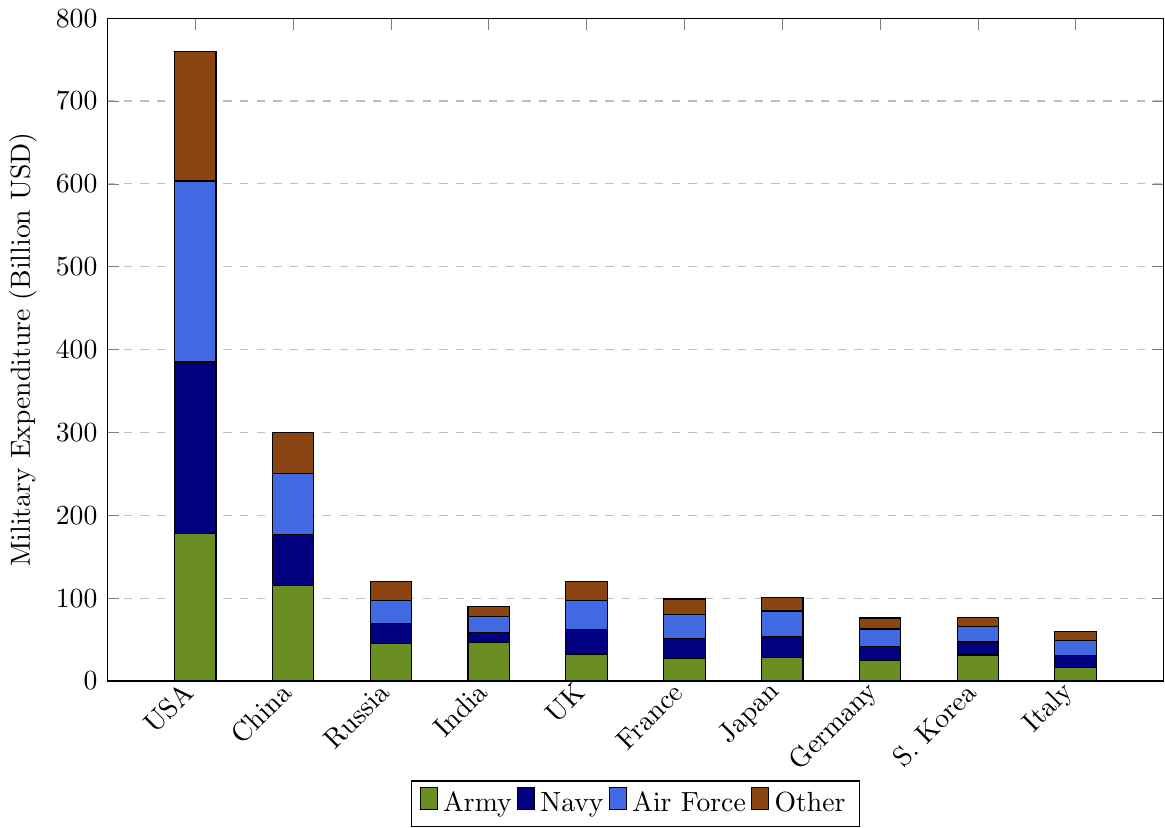What is the total military expenditure of China? To find the total military expenditure of China, sum up expenditures across all branches: Army (115.3), Navy (61.2), Air Force (73.4), and Other (50.1). The total is 115.3 + 61.2 + 73.4 + 50.1 = 300.0 billion USD.
Answer: 300.0 billion USD Which country spends the most on the Navy? Look at the bar representing the Navy for each country. The tallest bar corresponds to the United States with an expenditure of 207.1 billion USD.
Answer: United States What is the difference in Air Force expenditure between Japan and Germany? Find the Air Force expenditure for Japan (30.7 billion USD) and Germany (20.6 billion USD). The difference is 30.7 - 20.6 = 10.1 billion USD.
Answer: 10.1 billion USD How does Russia's total military expenditure compare to that of France? Sum up the military expenditures for Russia (Army: 45.2, Navy: 23.8, Air Force: 28.6, Other: 22.4) and France (Army: 26.9, Navy: 24.5, Air Force: 29.3, Other: 18.3). Russia’s total is 45.2 + 23.8 + 28.6 + 22.4 = 120.0, and France's total is 26.9 + 24.5 + 29.3 + 18.3 = 99.0 billion USD. Russia spends 21 billion USD more.
Answer: Russia spends 21 billion USD more than France Which country spends the least on the Army? Look at the bar representing the Army for each country and identify the shortest bar. Italy's Army expenditure is 16.2 billion USD, which is the lowest.
Answer: Italy What is the combined expenditure on the Air Force for all countries? Sum up the Air Force expenditures for all countries: USA (218.4), China (73.4), Russia (28.6), India (18.9), UK (35.7), France (29.3), Japan (30.7), Germany (20.6), S. Korea (18.8), and Italy (17.7). The total is 218.4 + 73.4 + 28.6 + 18.9 + 35.7 + 29.3 + 30.7 + 20.6 + 18.8 + 17.7 = 492.1 billion USD.
Answer: 492.1 billion USD What is the average expenditure on the Navy across all countries? Sum up the Navy expenditures for all countries: USA (207.1), China (61.2), Russia (23.8), India (11.8), UK (29.8), France (24.5), Japan (25.6), Germany (17.3), S. Korea (15.7), and Italy (14.8). The total is 431.6 billion USD. The average is 431.6 / 10 = 43.16 billion USD.
Answer: 43.16 billion USD What is the ratio of the United States' expenditure on the Air Force to its expenditure on the Army? The Air Force expenditure of the United States is 218.4 billion USD, and the Army expenditure is 177.9 billion USD. The ratio is 218.4 / 177.9, which simplifies to approximately 1.23.
Answer: 1.23 Which two countries have equal "Other" military expenditures, and what is that value? Look at the "Other" category for all countries. Both Russia and the UK have expenditure of 22.4 billion USD in this category.
Answer: Russia and the UK, 22.4 billion USD 